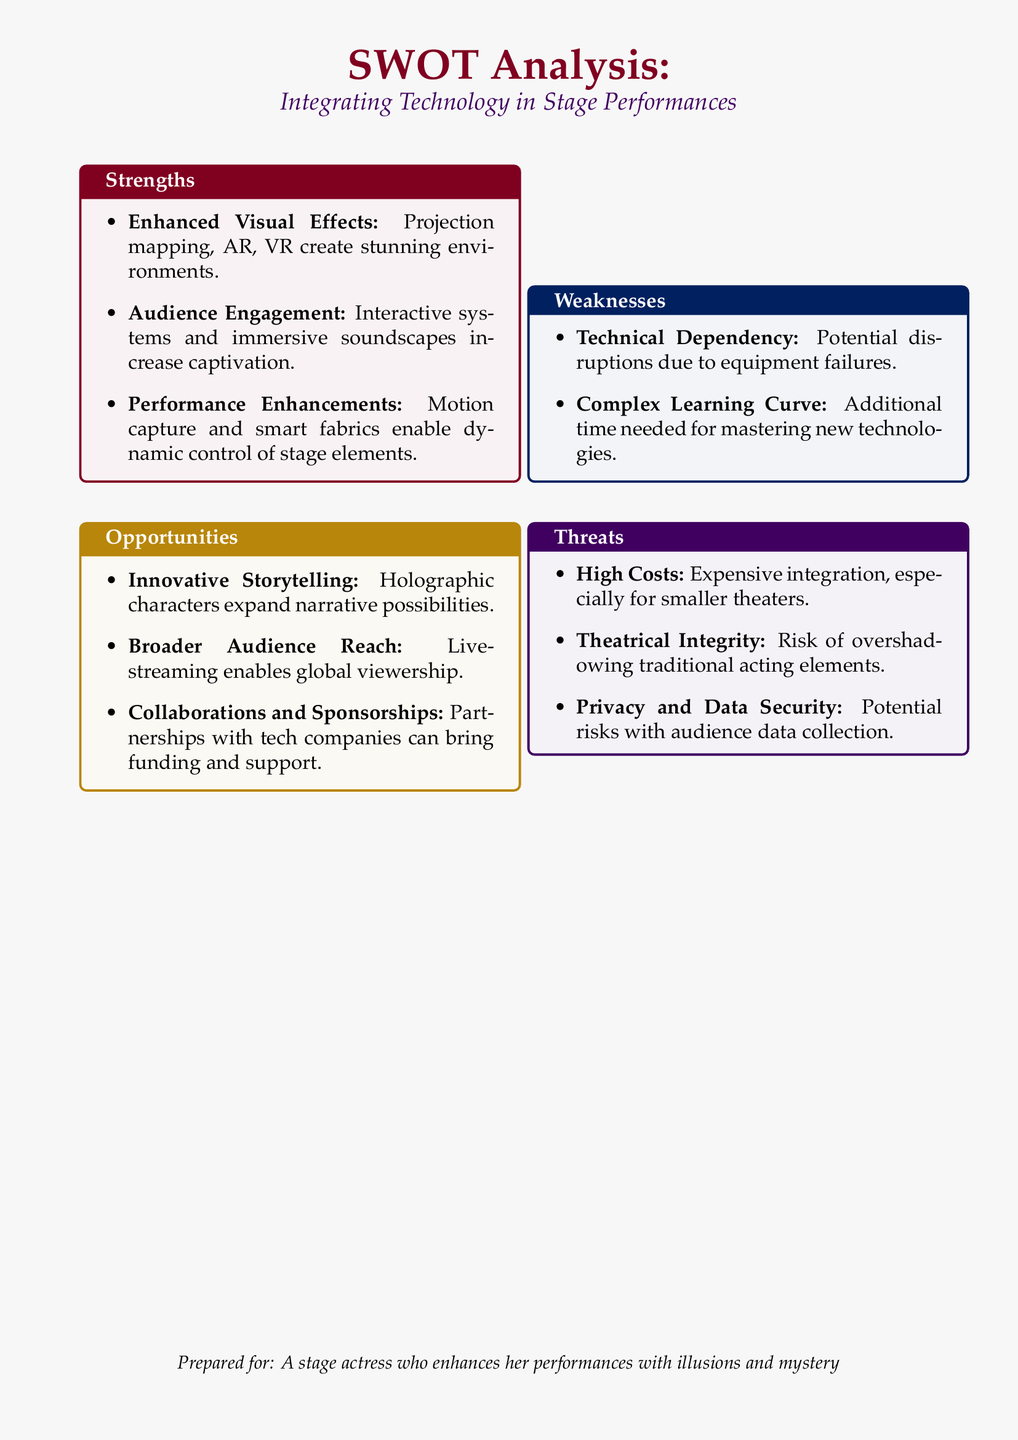what are the three strengths mentioned? The strengths listed are: Enhanced Visual Effects, Audience Engagement, and Performance Enhancements.
Answer: Enhanced Visual Effects, Audience Engagement, Performance Enhancements what is an example of an opportunity provided? The document mentions Innovative Storytelling as an opportunity.
Answer: Innovative Storytelling how many weaknesses are identified in the document? There are two weaknesses identified in the SWOT analysis.
Answer: 2 what potential risk is associated with audience data collection? The SWOT analysis mentions Privacy and Data Security as a threat related to audience data collection.
Answer: Privacy and Data Security what is a threat related to cost? High Costs is a specific threat mentioned in the SWOT analysis.
Answer: High Costs which technology can enhance audience engagement? Interactive systems are mentioned as a means to enhance audience engagement.
Answer: Interactive systems what does the document suggest regarding collaborations? The document suggests that collaborations with tech companies can bring funding and support.
Answer: Collaborations with tech companies what might overshadow traditional acting elements? The risk highlighted is the potential overshadowing of traditional acting elements by technology.
Answer: overshadowing traditional acting elements 